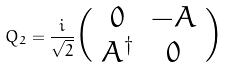<formula> <loc_0><loc_0><loc_500><loc_500>Q _ { 2 } = \frac { i } { \sqrt { 2 } } \Big { ( } \begin{array} { c c c } 0 & - A \\ A ^ { \dag } & 0 \\ \end{array} \Big { ) }</formula> 